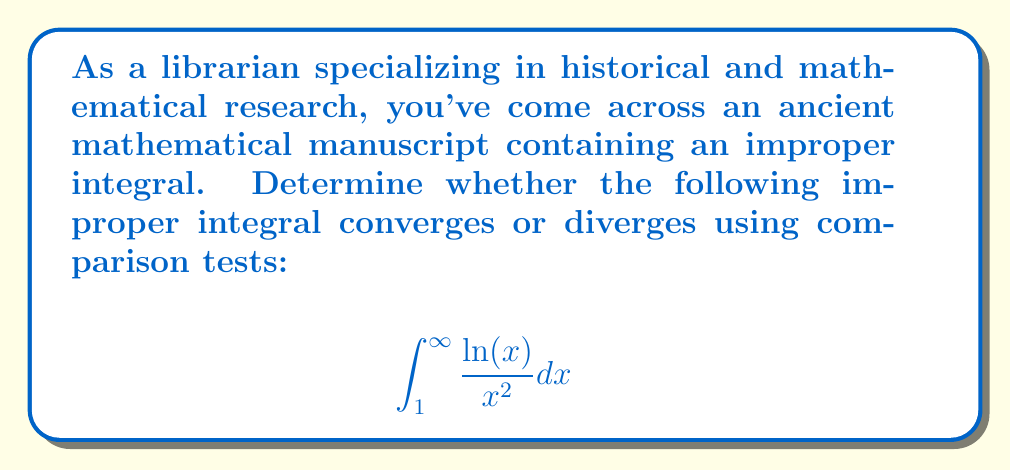Can you answer this question? To determine the convergence or divergence of this improper integral, we'll use the comparison test. Let's approach this step-by-step:

1) First, let's consider the behavior of $\frac{\ln(x)}{x^2}$ as $x$ approaches infinity.

2) We know that $\ln(x)$ grows more slowly than any positive power of $x$. In particular, for $x > e$, we have $\ln(x) < x^{1/2}$.

3) Therefore, for $x > e$, we can establish the following inequality:

   $$\frac{\ln(x)}{x^2} < \frac{x^{1/2}}{x^2} = \frac{1}{x^{3/2}}$$

4) Now, let's consider the integral of our upper bound:

   $$\int_e^{\infty} \frac{1}{x^{3/2}} dx$$

5) This is a p-integral with $p = 3/2 > 1$, which we know converges.

6) By the comparison test, if $\int_e^{\infty} \frac{1}{x^{3/2}} dx$ converges, then $\int_e^{\infty} \frac{\ln(x)}{x^2} dx$ must also converge.

7) The original integral starts from 1, not e. However, $\int_1^e \frac{\ln(x)}{x^2} dx$ is a definite integral over a finite interval where the integrand is continuous, so it's finite.

8) The sum of a finite value and a convergent improper integral is convergent.

Therefore, we can conclude that $\int_1^{\infty} \frac{\ln(x)}{x^2} dx$ converges.
Answer: Converges 